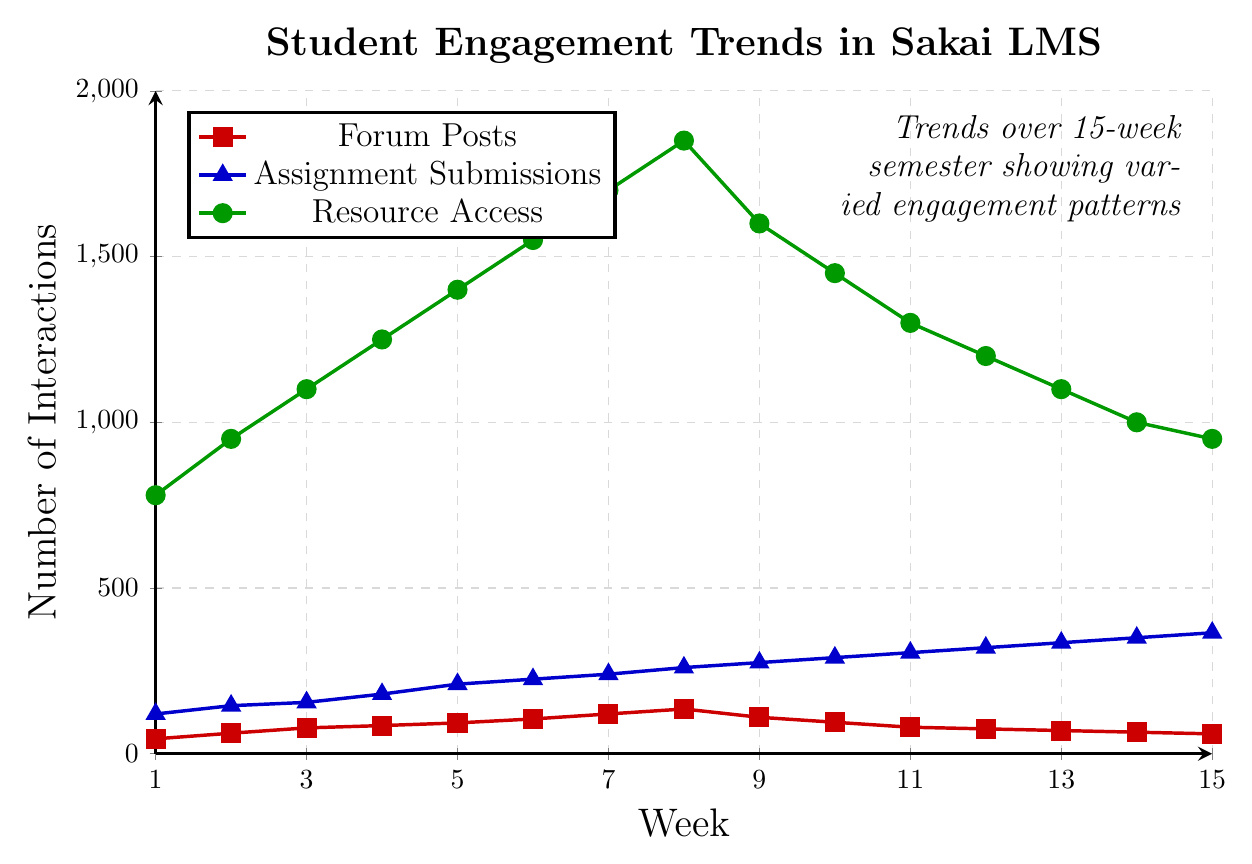What are the peak values for forum posts, assignment submissions, and resource access? The peak values are the highest data points for each category during the semester. For forum posts, this is Week 8 with 135 posts. For assignment submissions, it is Week 15 with 365 submissions. For resource access, it is Week 8 with 1850 accesses.
Answer: 135, 365, 1850 Do assignment submissions consistently increase throughout the semester? Observing the assignment submissions trend, it shows a consistent increase from Week 1 (120 submissions) to Week 15 (365 submissions) without any dips.
Answer: Yes When do forum posts start to decline? Forum posts start to decline after reaching a peak value of 135 posts in Week 8. The decline can be observed from Week 9 onward.
Answer: Week 9 How does the number of resource accesses in Week 9 compare to Week 8? In Week 8, the resource accesses are at 1850, while in Week 9, it decreases to 1600. Thus, Week 9 has 250 fewer resource accesses compared to Week 8.
Answer: Week 9 has 250 fewer What is the trend in assignment submissions between Week 11 and Week 15? From Week 11 to Week 15, assignment submissions increase each week: Week 11 (305), Week 12 (320), Week 13 (335), Week 14 (350), and Week 15 (365).
Answer: Increasing Which week has the lowest forum posts and what is the value? The lowest value of forum posts is in Week 15 with 60 posts.
Answer: Week 15, 60 posts Compare the resource access between the start and end of the semester. In Week 1, resource access is at 780, while in Week 15, it is at 950. This shows an increase of 170 accesses from the start to the end of the semester.
Answer: Increased by 170 How does the trend for forum posts differ from the trend for assignment submissions? Forum posts initially increase and then start to decline after Week 8. In contrast, assignment submissions show a steady increase throughout the 15 weeks.
Answer: Forum posts decline, assignment submissions increase 